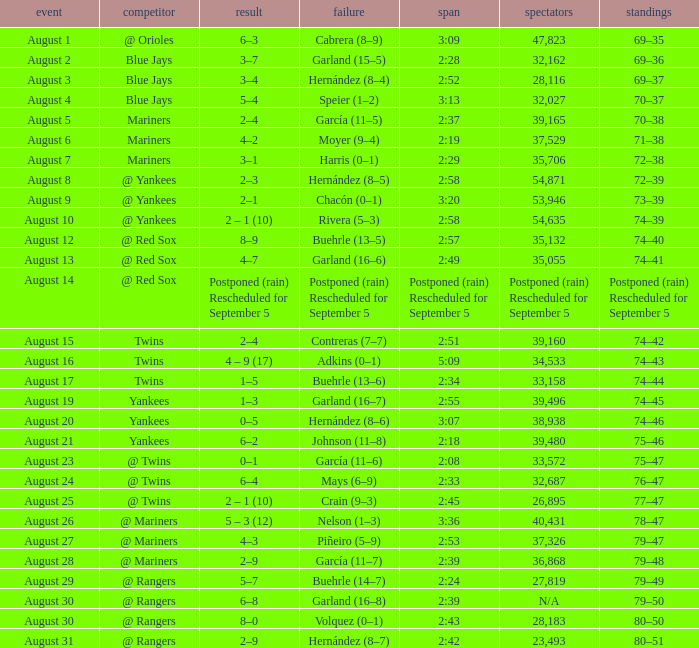Who lost on August 27? Piñeiro (5–9). 